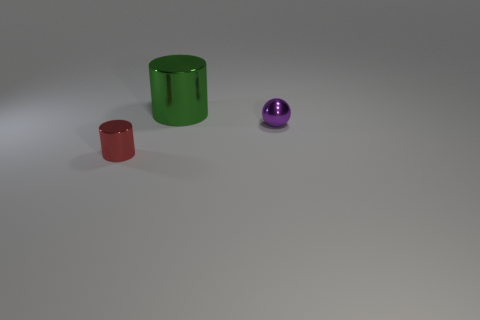Subtract all green cylinders. How many cylinders are left? 1 Add 1 small gray metallic things. How many objects exist? 4 Subtract all cylinders. How many objects are left? 1 Subtract 1 cylinders. How many cylinders are left? 1 Subtract all big green cylinders. Subtract all large green cylinders. How many objects are left? 1 Add 3 red things. How many red things are left? 4 Add 2 metal cylinders. How many metal cylinders exist? 4 Subtract 1 purple spheres. How many objects are left? 2 Subtract all blue spheres. Subtract all purple cubes. How many spheres are left? 1 Subtract all red cubes. How many green cylinders are left? 1 